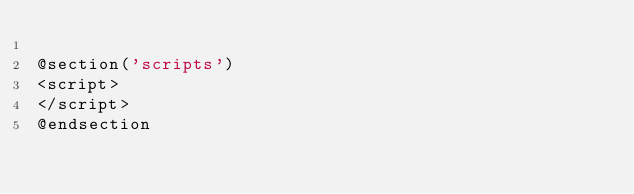<code> <loc_0><loc_0><loc_500><loc_500><_PHP_>
@section('scripts')
<script>
</script>
@endsection</code> 